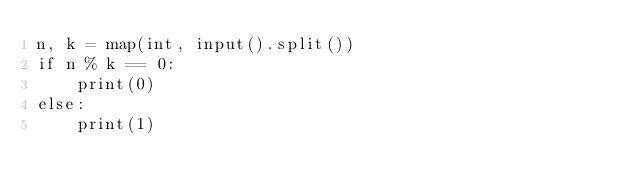<code> <loc_0><loc_0><loc_500><loc_500><_Python_>n, k = map(int, input().split())
if n % k == 0:
    print(0)
else:
    print(1)</code> 